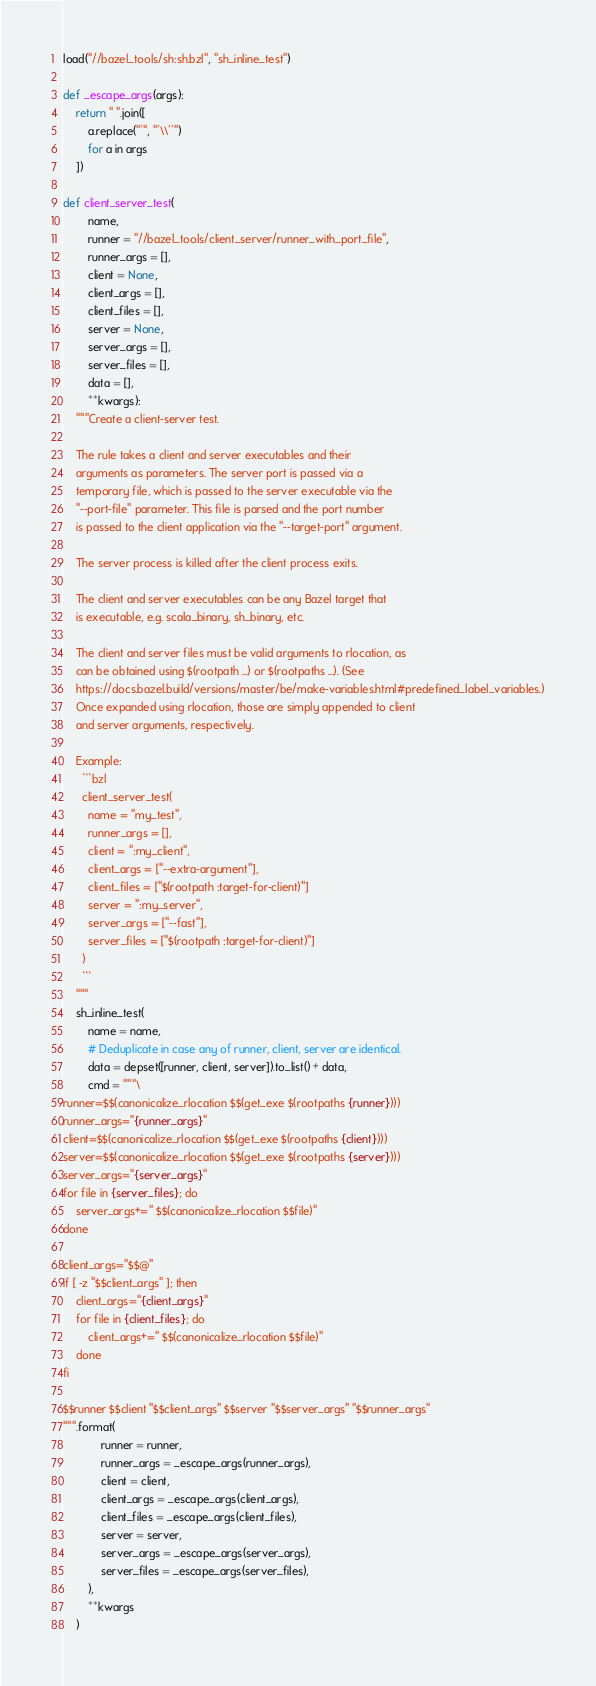Convert code to text. <code><loc_0><loc_0><loc_500><loc_500><_Python_>
load("//bazel_tools/sh:sh.bzl", "sh_inline_test")

def _escape_args(args):
    return " ".join([
        a.replace("'", "'\\''")
        for a in args
    ])

def client_server_test(
        name,
        runner = "//bazel_tools/client_server/runner_with_port_file",
        runner_args = [],
        client = None,
        client_args = [],
        client_files = [],
        server = None,
        server_args = [],
        server_files = [],
        data = [],
        **kwargs):
    """Create a client-server test.

    The rule takes a client and server executables and their
    arguments as parameters. The server port is passed via a
    temporary file, which is passed to the server executable via the
    "--port-file" parameter. This file is parsed and the port number
    is passed to the client application via the "--target-port" argument.

    The server process is killed after the client process exits.

    The client and server executables can be any Bazel target that
    is executable, e.g. scala_binary, sh_binary, etc.

    The client and server files must be valid arguments to rlocation, as
    can be obtained using $(rootpath ...) or $(rootpaths ...). (See
    https://docs.bazel.build/versions/master/be/make-variables.html#predefined_label_variables.)
    Once expanded using rlocation, those are simply appended to client
    and server arguments, respectively.

    Example:
      ```bzl
      client_server_test(
        name = "my_test",
        runner_args = [],
        client = ":my_client",
        client_args = ["--extra-argument"],
        client_files = ["$(rootpath :target-for-client)"]
        server = ":my_server",
        server_args = ["--fast"],
        server_files = ["$(rootpath :target-for-client)"]
      )
      ```
    """
    sh_inline_test(
        name = name,
        # Deduplicate in case any of runner, client, server are identical.
        data = depset([runner, client, server]).to_list() + data,
        cmd = """\
runner=$$(canonicalize_rlocation $$(get_exe $(rootpaths {runner})))
runner_args="{runner_args}"
client=$$(canonicalize_rlocation $$(get_exe $(rootpaths {client})))
server=$$(canonicalize_rlocation $$(get_exe $(rootpaths {server})))
server_args="{server_args}"
for file in {server_files}; do
    server_args+=" $$(canonicalize_rlocation $$file)"
done

client_args="$$@"
if [ -z "$$client_args" ]; then
    client_args="{client_args}"
    for file in {client_files}; do
        client_args+=" $$(canonicalize_rlocation $$file)"
    done
fi

$$runner $$client "$$client_args" $$server "$$server_args" "$$runner_args"
""".format(
            runner = runner,
            runner_args = _escape_args(runner_args),
            client = client,
            client_args = _escape_args(client_args),
            client_files = _escape_args(client_files),
            server = server,
            server_args = _escape_args(server_args),
            server_files = _escape_args(server_files),
        ),
        **kwargs
    )
</code> 